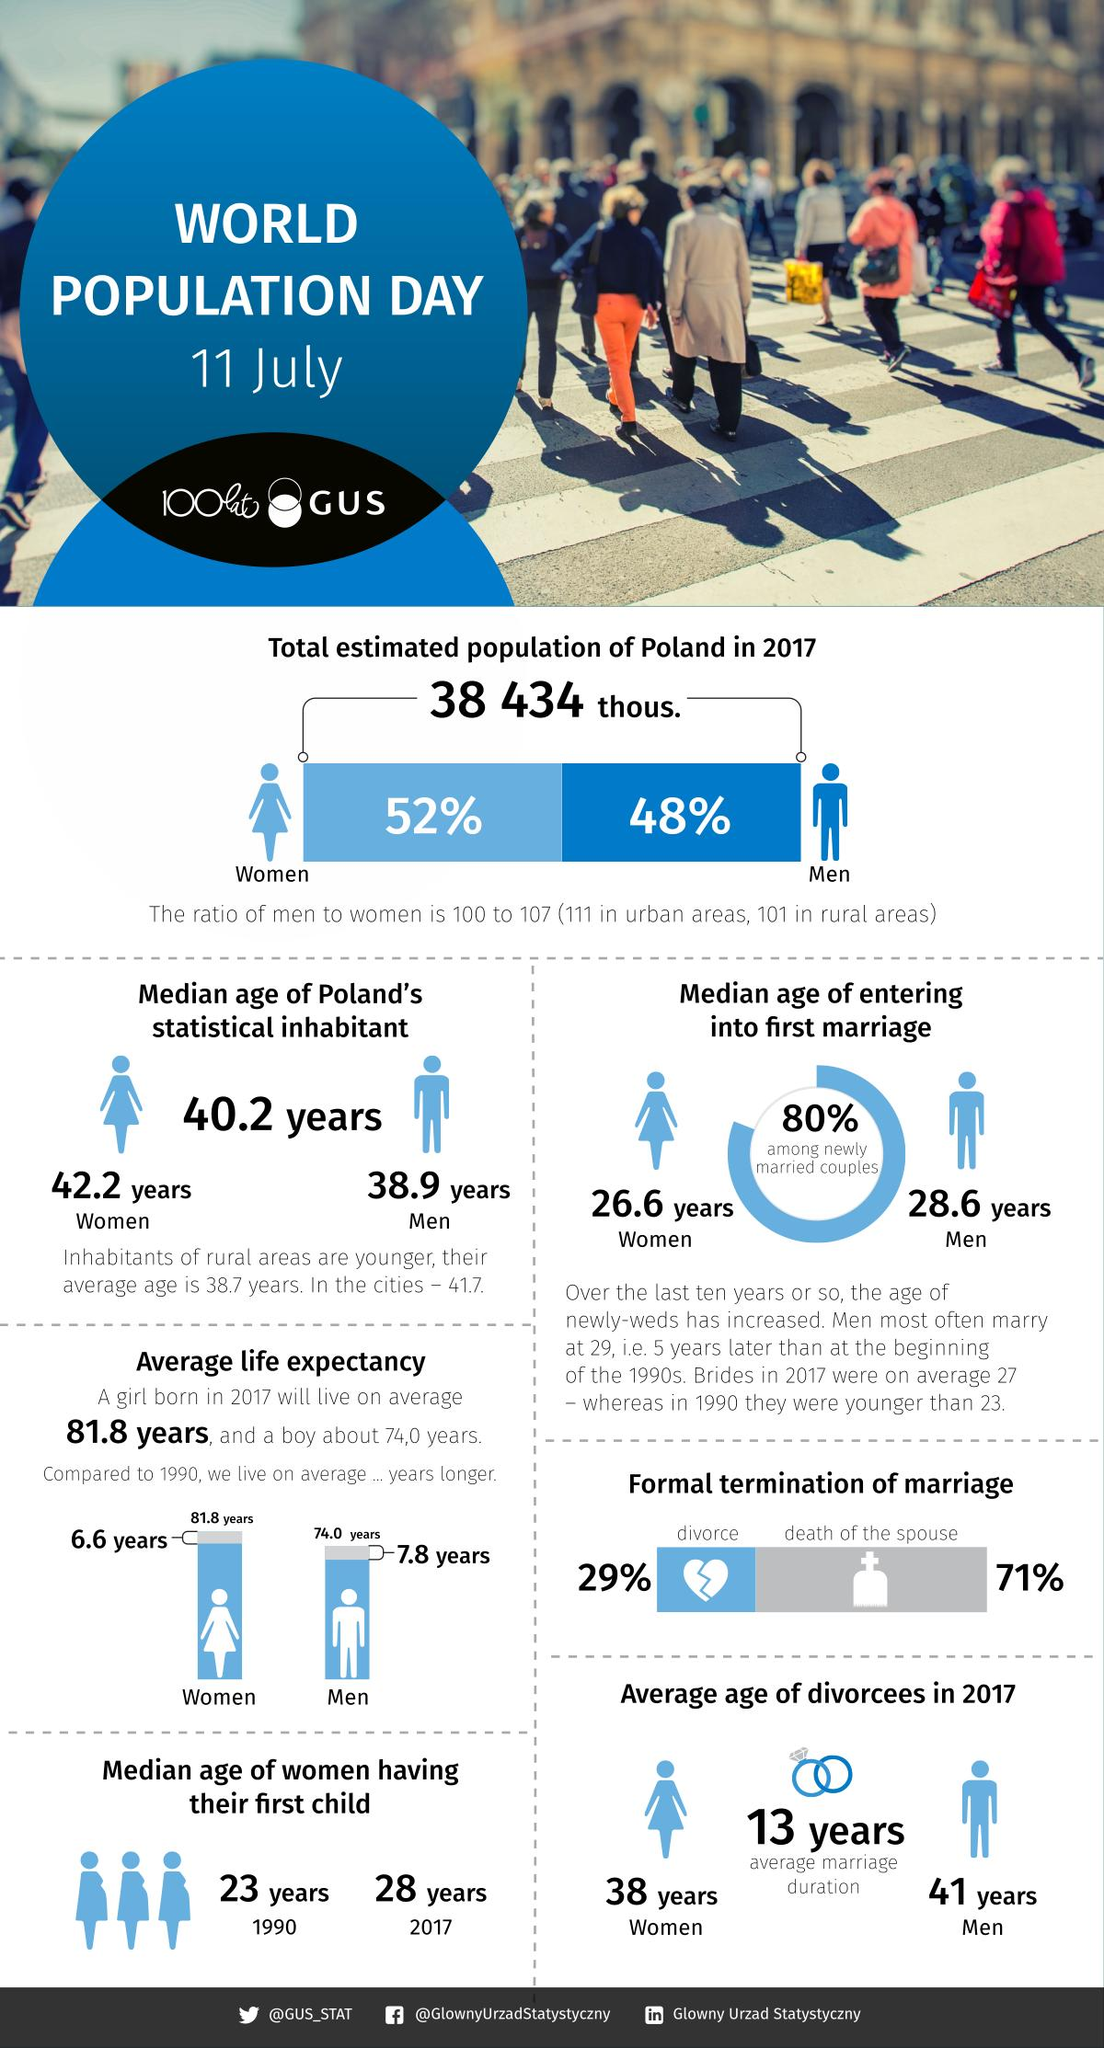Mention a couple of crucial points in this snapshot. The median age of women having their first child in 2017 was 25 years younger than in 1990, which was 5 years. The average life expectancy for a boy born in 1990 is 66.2 years, according to data. The average life expectancy for a girl born in 1990 is 75.2 years. 